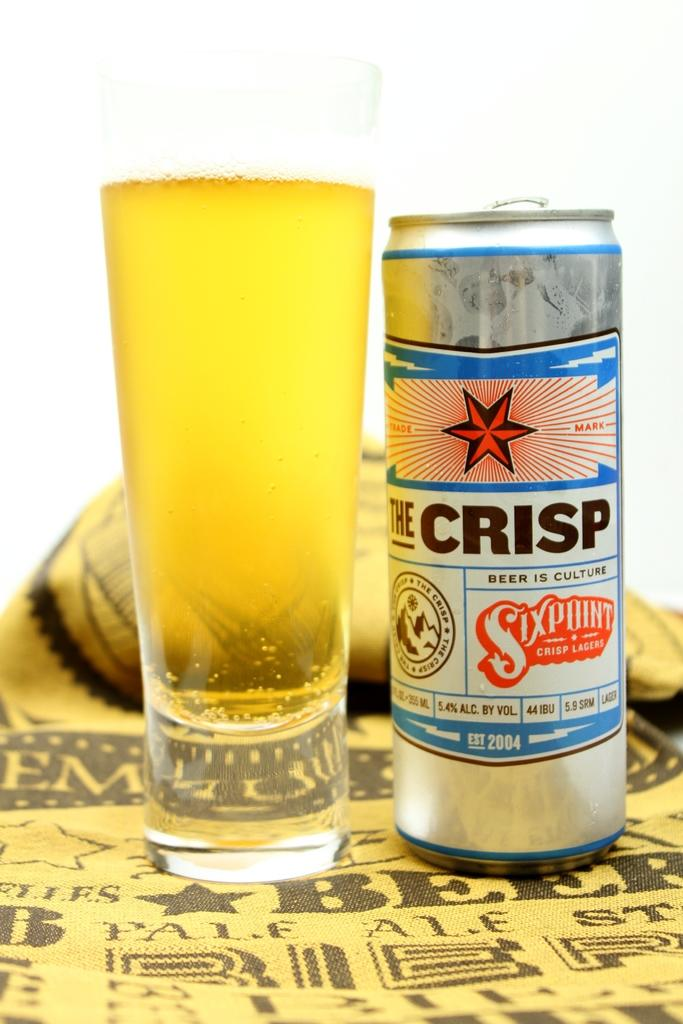<image>
Write a terse but informative summary of the picture. A can of drink called The Crisp and a glass. 